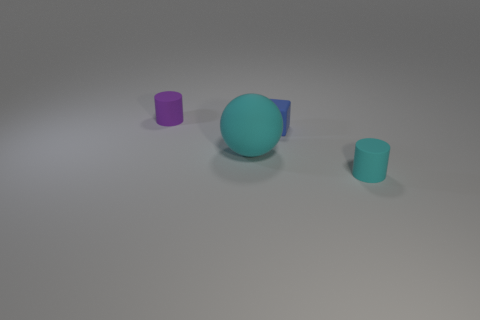Are the colors on the objects indicative of their material? Not necessarily. While color can sometimes give clues about material, in this stylized image, it is more likely that the colors were chosen for aesthetic purposes rather than to indicate specific materials. How can we guess the material then? Materials can often be inferred by the texture and reflective properties observed. In this case, the velvety, matte finish of the objects suggests they could be made of diffuse materials like plastic, ceramic, or painted surfaces. 